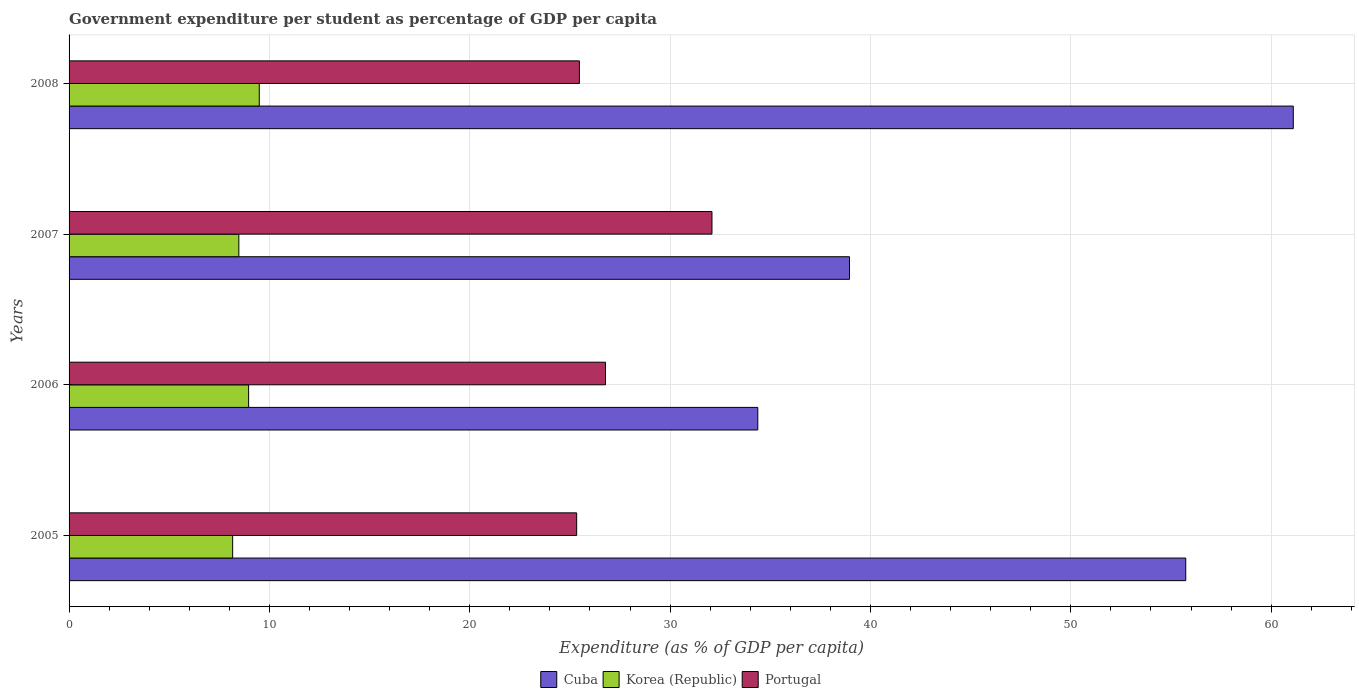How many different coloured bars are there?
Your answer should be very brief. 3. How many groups of bars are there?
Make the answer very short. 4. Are the number of bars on each tick of the Y-axis equal?
Your answer should be very brief. Yes. How many bars are there on the 4th tick from the top?
Your response must be concise. 3. In how many cases, is the number of bars for a given year not equal to the number of legend labels?
Your answer should be compact. 0. What is the percentage of expenditure per student in Cuba in 2008?
Your answer should be very brief. 61.1. Across all years, what is the maximum percentage of expenditure per student in Portugal?
Keep it short and to the point. 32.09. Across all years, what is the minimum percentage of expenditure per student in Portugal?
Give a very brief answer. 25.34. In which year was the percentage of expenditure per student in Portugal maximum?
Your answer should be compact. 2007. What is the total percentage of expenditure per student in Cuba in the graph?
Ensure brevity in your answer.  190.17. What is the difference between the percentage of expenditure per student in Portugal in 2007 and that in 2008?
Make the answer very short. 6.62. What is the difference between the percentage of expenditure per student in Portugal in 2006 and the percentage of expenditure per student in Cuba in 2005?
Keep it short and to the point. -28.96. What is the average percentage of expenditure per student in Cuba per year?
Give a very brief answer. 47.54. In the year 2008, what is the difference between the percentage of expenditure per student in Korea (Republic) and percentage of expenditure per student in Cuba?
Ensure brevity in your answer.  -51.61. In how many years, is the percentage of expenditure per student in Cuba greater than 18 %?
Your response must be concise. 4. What is the ratio of the percentage of expenditure per student in Korea (Republic) in 2007 to that in 2008?
Offer a very short reply. 0.89. Is the difference between the percentage of expenditure per student in Korea (Republic) in 2005 and 2007 greater than the difference between the percentage of expenditure per student in Cuba in 2005 and 2007?
Keep it short and to the point. No. What is the difference between the highest and the second highest percentage of expenditure per student in Cuba?
Offer a very short reply. 5.37. What is the difference between the highest and the lowest percentage of expenditure per student in Korea (Republic)?
Your response must be concise. 1.33. What does the 3rd bar from the top in 2008 represents?
Provide a succinct answer. Cuba. What does the 1st bar from the bottom in 2007 represents?
Your response must be concise. Cuba. How many bars are there?
Provide a short and direct response. 12. Are all the bars in the graph horizontal?
Provide a succinct answer. Yes. How many years are there in the graph?
Your response must be concise. 4. Are the values on the major ticks of X-axis written in scientific E-notation?
Ensure brevity in your answer.  No. Does the graph contain any zero values?
Provide a succinct answer. No. Does the graph contain grids?
Provide a short and direct response. Yes. Where does the legend appear in the graph?
Offer a very short reply. Bottom center. How are the legend labels stacked?
Offer a very short reply. Horizontal. What is the title of the graph?
Ensure brevity in your answer.  Government expenditure per student as percentage of GDP per capita. What is the label or title of the X-axis?
Make the answer very short. Expenditure (as % of GDP per capita). What is the Expenditure (as % of GDP per capita) in Cuba in 2005?
Ensure brevity in your answer.  55.74. What is the Expenditure (as % of GDP per capita) in Korea (Republic) in 2005?
Ensure brevity in your answer.  8.17. What is the Expenditure (as % of GDP per capita) in Portugal in 2005?
Offer a very short reply. 25.34. What is the Expenditure (as % of GDP per capita) of Cuba in 2006?
Provide a short and direct response. 34.38. What is the Expenditure (as % of GDP per capita) in Korea (Republic) in 2006?
Your answer should be very brief. 8.96. What is the Expenditure (as % of GDP per capita) of Portugal in 2006?
Your answer should be very brief. 26.78. What is the Expenditure (as % of GDP per capita) in Cuba in 2007?
Offer a terse response. 38.96. What is the Expenditure (as % of GDP per capita) in Korea (Republic) in 2007?
Offer a very short reply. 8.47. What is the Expenditure (as % of GDP per capita) of Portugal in 2007?
Offer a very short reply. 32.09. What is the Expenditure (as % of GDP per capita) of Cuba in 2008?
Offer a terse response. 61.1. What is the Expenditure (as % of GDP per capita) of Korea (Republic) in 2008?
Your answer should be very brief. 9.49. What is the Expenditure (as % of GDP per capita) of Portugal in 2008?
Offer a very short reply. 25.47. Across all years, what is the maximum Expenditure (as % of GDP per capita) of Cuba?
Your answer should be very brief. 61.1. Across all years, what is the maximum Expenditure (as % of GDP per capita) in Korea (Republic)?
Your response must be concise. 9.49. Across all years, what is the maximum Expenditure (as % of GDP per capita) of Portugal?
Make the answer very short. 32.09. Across all years, what is the minimum Expenditure (as % of GDP per capita) of Cuba?
Make the answer very short. 34.38. Across all years, what is the minimum Expenditure (as % of GDP per capita) in Korea (Republic)?
Offer a very short reply. 8.17. Across all years, what is the minimum Expenditure (as % of GDP per capita) of Portugal?
Your answer should be very brief. 25.34. What is the total Expenditure (as % of GDP per capita) of Cuba in the graph?
Offer a very short reply. 190.17. What is the total Expenditure (as % of GDP per capita) in Korea (Republic) in the graph?
Keep it short and to the point. 35.09. What is the total Expenditure (as % of GDP per capita) in Portugal in the graph?
Offer a terse response. 109.67. What is the difference between the Expenditure (as % of GDP per capita) in Cuba in 2005 and that in 2006?
Offer a terse response. 21.36. What is the difference between the Expenditure (as % of GDP per capita) of Korea (Republic) in 2005 and that in 2006?
Provide a short and direct response. -0.8. What is the difference between the Expenditure (as % of GDP per capita) of Portugal in 2005 and that in 2006?
Make the answer very short. -1.44. What is the difference between the Expenditure (as % of GDP per capita) of Cuba in 2005 and that in 2007?
Your response must be concise. 16.78. What is the difference between the Expenditure (as % of GDP per capita) in Korea (Republic) in 2005 and that in 2007?
Keep it short and to the point. -0.31. What is the difference between the Expenditure (as % of GDP per capita) of Portugal in 2005 and that in 2007?
Give a very brief answer. -6.75. What is the difference between the Expenditure (as % of GDP per capita) in Cuba in 2005 and that in 2008?
Provide a succinct answer. -5.37. What is the difference between the Expenditure (as % of GDP per capita) of Korea (Republic) in 2005 and that in 2008?
Give a very brief answer. -1.33. What is the difference between the Expenditure (as % of GDP per capita) of Portugal in 2005 and that in 2008?
Offer a very short reply. -0.14. What is the difference between the Expenditure (as % of GDP per capita) of Cuba in 2006 and that in 2007?
Your answer should be very brief. -4.58. What is the difference between the Expenditure (as % of GDP per capita) of Korea (Republic) in 2006 and that in 2007?
Your answer should be very brief. 0.49. What is the difference between the Expenditure (as % of GDP per capita) of Portugal in 2006 and that in 2007?
Give a very brief answer. -5.31. What is the difference between the Expenditure (as % of GDP per capita) of Cuba in 2006 and that in 2008?
Keep it short and to the point. -26.73. What is the difference between the Expenditure (as % of GDP per capita) in Korea (Republic) in 2006 and that in 2008?
Keep it short and to the point. -0.53. What is the difference between the Expenditure (as % of GDP per capita) of Portugal in 2006 and that in 2008?
Provide a succinct answer. 1.3. What is the difference between the Expenditure (as % of GDP per capita) of Cuba in 2007 and that in 2008?
Your answer should be very brief. -22.15. What is the difference between the Expenditure (as % of GDP per capita) in Korea (Republic) in 2007 and that in 2008?
Your answer should be very brief. -1.02. What is the difference between the Expenditure (as % of GDP per capita) of Portugal in 2007 and that in 2008?
Your answer should be very brief. 6.62. What is the difference between the Expenditure (as % of GDP per capita) of Cuba in 2005 and the Expenditure (as % of GDP per capita) of Korea (Republic) in 2006?
Give a very brief answer. 46.78. What is the difference between the Expenditure (as % of GDP per capita) of Cuba in 2005 and the Expenditure (as % of GDP per capita) of Portugal in 2006?
Ensure brevity in your answer.  28.96. What is the difference between the Expenditure (as % of GDP per capita) of Korea (Republic) in 2005 and the Expenditure (as % of GDP per capita) of Portugal in 2006?
Ensure brevity in your answer.  -18.61. What is the difference between the Expenditure (as % of GDP per capita) in Cuba in 2005 and the Expenditure (as % of GDP per capita) in Korea (Republic) in 2007?
Your answer should be compact. 47.26. What is the difference between the Expenditure (as % of GDP per capita) of Cuba in 2005 and the Expenditure (as % of GDP per capita) of Portugal in 2007?
Provide a short and direct response. 23.65. What is the difference between the Expenditure (as % of GDP per capita) of Korea (Republic) in 2005 and the Expenditure (as % of GDP per capita) of Portugal in 2007?
Offer a terse response. -23.92. What is the difference between the Expenditure (as % of GDP per capita) of Cuba in 2005 and the Expenditure (as % of GDP per capita) of Korea (Republic) in 2008?
Your answer should be very brief. 46.24. What is the difference between the Expenditure (as % of GDP per capita) in Cuba in 2005 and the Expenditure (as % of GDP per capita) in Portugal in 2008?
Provide a succinct answer. 30.27. What is the difference between the Expenditure (as % of GDP per capita) in Korea (Republic) in 2005 and the Expenditure (as % of GDP per capita) in Portugal in 2008?
Ensure brevity in your answer.  -17.31. What is the difference between the Expenditure (as % of GDP per capita) of Cuba in 2006 and the Expenditure (as % of GDP per capita) of Korea (Republic) in 2007?
Offer a terse response. 25.9. What is the difference between the Expenditure (as % of GDP per capita) of Cuba in 2006 and the Expenditure (as % of GDP per capita) of Portugal in 2007?
Your answer should be very brief. 2.29. What is the difference between the Expenditure (as % of GDP per capita) of Korea (Republic) in 2006 and the Expenditure (as % of GDP per capita) of Portugal in 2007?
Your answer should be very brief. -23.13. What is the difference between the Expenditure (as % of GDP per capita) of Cuba in 2006 and the Expenditure (as % of GDP per capita) of Korea (Republic) in 2008?
Your response must be concise. 24.88. What is the difference between the Expenditure (as % of GDP per capita) in Cuba in 2006 and the Expenditure (as % of GDP per capita) in Portugal in 2008?
Make the answer very short. 8.9. What is the difference between the Expenditure (as % of GDP per capita) of Korea (Republic) in 2006 and the Expenditure (as % of GDP per capita) of Portugal in 2008?
Make the answer very short. -16.51. What is the difference between the Expenditure (as % of GDP per capita) of Cuba in 2007 and the Expenditure (as % of GDP per capita) of Korea (Republic) in 2008?
Provide a succinct answer. 29.46. What is the difference between the Expenditure (as % of GDP per capita) in Cuba in 2007 and the Expenditure (as % of GDP per capita) in Portugal in 2008?
Keep it short and to the point. 13.48. What is the difference between the Expenditure (as % of GDP per capita) of Korea (Republic) in 2007 and the Expenditure (as % of GDP per capita) of Portugal in 2008?
Make the answer very short. -17. What is the average Expenditure (as % of GDP per capita) in Cuba per year?
Your answer should be compact. 47.54. What is the average Expenditure (as % of GDP per capita) in Korea (Republic) per year?
Offer a very short reply. 8.77. What is the average Expenditure (as % of GDP per capita) in Portugal per year?
Your response must be concise. 27.42. In the year 2005, what is the difference between the Expenditure (as % of GDP per capita) of Cuba and Expenditure (as % of GDP per capita) of Korea (Republic)?
Keep it short and to the point. 47.57. In the year 2005, what is the difference between the Expenditure (as % of GDP per capita) in Cuba and Expenditure (as % of GDP per capita) in Portugal?
Make the answer very short. 30.4. In the year 2005, what is the difference between the Expenditure (as % of GDP per capita) of Korea (Republic) and Expenditure (as % of GDP per capita) of Portugal?
Make the answer very short. -17.17. In the year 2006, what is the difference between the Expenditure (as % of GDP per capita) in Cuba and Expenditure (as % of GDP per capita) in Korea (Republic)?
Provide a succinct answer. 25.41. In the year 2006, what is the difference between the Expenditure (as % of GDP per capita) of Cuba and Expenditure (as % of GDP per capita) of Portugal?
Provide a short and direct response. 7.6. In the year 2006, what is the difference between the Expenditure (as % of GDP per capita) in Korea (Republic) and Expenditure (as % of GDP per capita) in Portugal?
Give a very brief answer. -17.81. In the year 2007, what is the difference between the Expenditure (as % of GDP per capita) in Cuba and Expenditure (as % of GDP per capita) in Korea (Republic)?
Keep it short and to the point. 30.48. In the year 2007, what is the difference between the Expenditure (as % of GDP per capita) of Cuba and Expenditure (as % of GDP per capita) of Portugal?
Keep it short and to the point. 6.87. In the year 2007, what is the difference between the Expenditure (as % of GDP per capita) in Korea (Republic) and Expenditure (as % of GDP per capita) in Portugal?
Provide a succinct answer. -23.62. In the year 2008, what is the difference between the Expenditure (as % of GDP per capita) in Cuba and Expenditure (as % of GDP per capita) in Korea (Republic)?
Provide a short and direct response. 51.61. In the year 2008, what is the difference between the Expenditure (as % of GDP per capita) in Cuba and Expenditure (as % of GDP per capita) in Portugal?
Provide a short and direct response. 35.63. In the year 2008, what is the difference between the Expenditure (as % of GDP per capita) of Korea (Republic) and Expenditure (as % of GDP per capita) of Portugal?
Make the answer very short. -15.98. What is the ratio of the Expenditure (as % of GDP per capita) in Cuba in 2005 to that in 2006?
Ensure brevity in your answer.  1.62. What is the ratio of the Expenditure (as % of GDP per capita) in Korea (Republic) in 2005 to that in 2006?
Offer a terse response. 0.91. What is the ratio of the Expenditure (as % of GDP per capita) in Portugal in 2005 to that in 2006?
Your response must be concise. 0.95. What is the ratio of the Expenditure (as % of GDP per capita) in Cuba in 2005 to that in 2007?
Ensure brevity in your answer.  1.43. What is the ratio of the Expenditure (as % of GDP per capita) of Korea (Republic) in 2005 to that in 2007?
Ensure brevity in your answer.  0.96. What is the ratio of the Expenditure (as % of GDP per capita) in Portugal in 2005 to that in 2007?
Provide a short and direct response. 0.79. What is the ratio of the Expenditure (as % of GDP per capita) in Cuba in 2005 to that in 2008?
Provide a short and direct response. 0.91. What is the ratio of the Expenditure (as % of GDP per capita) in Korea (Republic) in 2005 to that in 2008?
Offer a very short reply. 0.86. What is the ratio of the Expenditure (as % of GDP per capita) in Portugal in 2005 to that in 2008?
Offer a terse response. 0.99. What is the ratio of the Expenditure (as % of GDP per capita) in Cuba in 2006 to that in 2007?
Provide a short and direct response. 0.88. What is the ratio of the Expenditure (as % of GDP per capita) in Korea (Republic) in 2006 to that in 2007?
Provide a short and direct response. 1.06. What is the ratio of the Expenditure (as % of GDP per capita) of Portugal in 2006 to that in 2007?
Your response must be concise. 0.83. What is the ratio of the Expenditure (as % of GDP per capita) in Cuba in 2006 to that in 2008?
Your answer should be compact. 0.56. What is the ratio of the Expenditure (as % of GDP per capita) in Korea (Republic) in 2006 to that in 2008?
Provide a succinct answer. 0.94. What is the ratio of the Expenditure (as % of GDP per capita) of Portugal in 2006 to that in 2008?
Give a very brief answer. 1.05. What is the ratio of the Expenditure (as % of GDP per capita) in Cuba in 2007 to that in 2008?
Keep it short and to the point. 0.64. What is the ratio of the Expenditure (as % of GDP per capita) in Korea (Republic) in 2007 to that in 2008?
Give a very brief answer. 0.89. What is the ratio of the Expenditure (as % of GDP per capita) of Portugal in 2007 to that in 2008?
Keep it short and to the point. 1.26. What is the difference between the highest and the second highest Expenditure (as % of GDP per capita) in Cuba?
Ensure brevity in your answer.  5.37. What is the difference between the highest and the second highest Expenditure (as % of GDP per capita) of Korea (Republic)?
Your answer should be very brief. 0.53. What is the difference between the highest and the second highest Expenditure (as % of GDP per capita) in Portugal?
Your answer should be compact. 5.31. What is the difference between the highest and the lowest Expenditure (as % of GDP per capita) of Cuba?
Offer a very short reply. 26.73. What is the difference between the highest and the lowest Expenditure (as % of GDP per capita) of Korea (Republic)?
Make the answer very short. 1.33. What is the difference between the highest and the lowest Expenditure (as % of GDP per capita) of Portugal?
Offer a terse response. 6.75. 